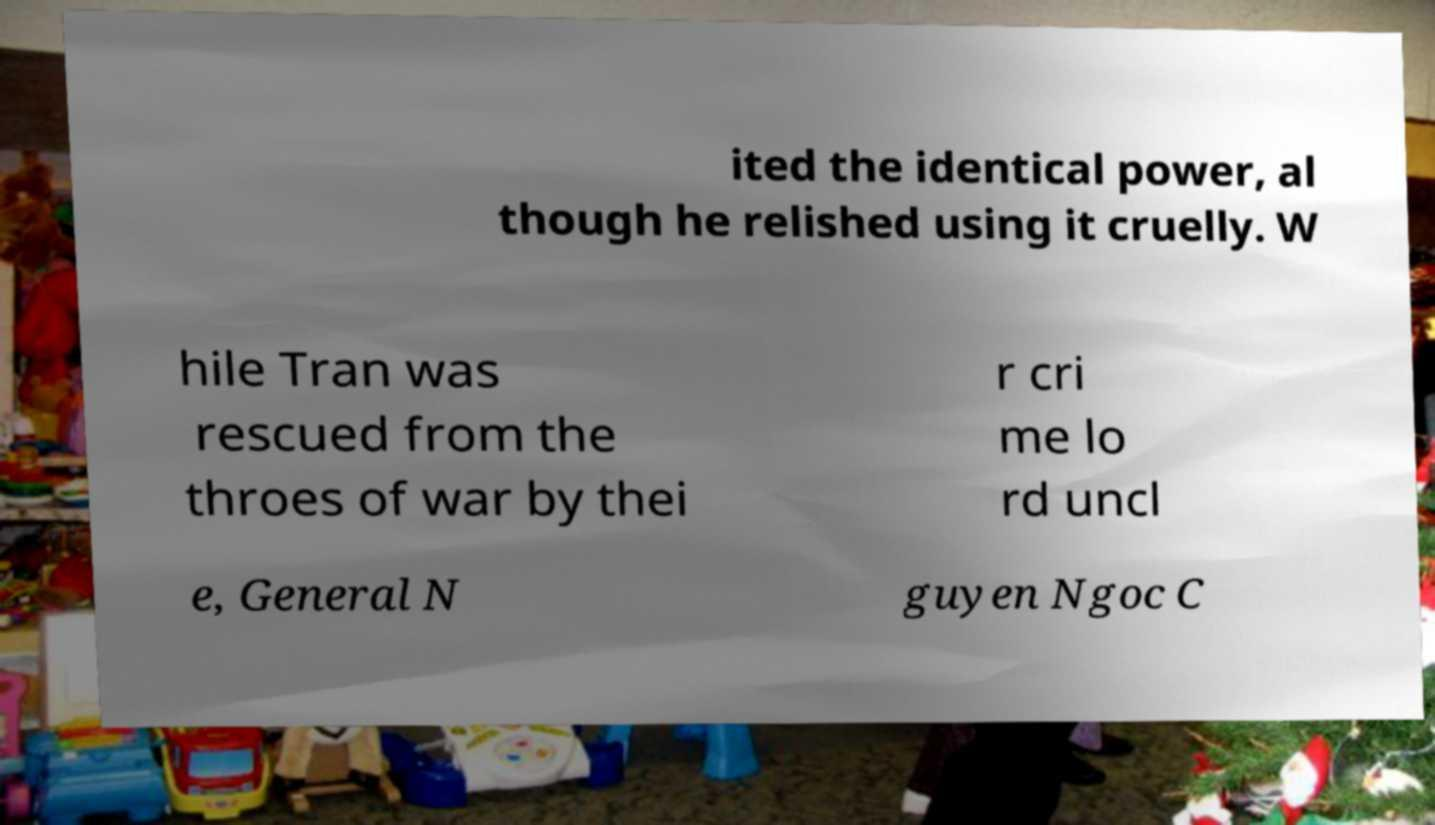There's text embedded in this image that I need extracted. Can you transcribe it verbatim? ited the identical power, al though he relished using it cruelly. W hile Tran was rescued from the throes of war by thei r cri me lo rd uncl e, General N guyen Ngoc C 